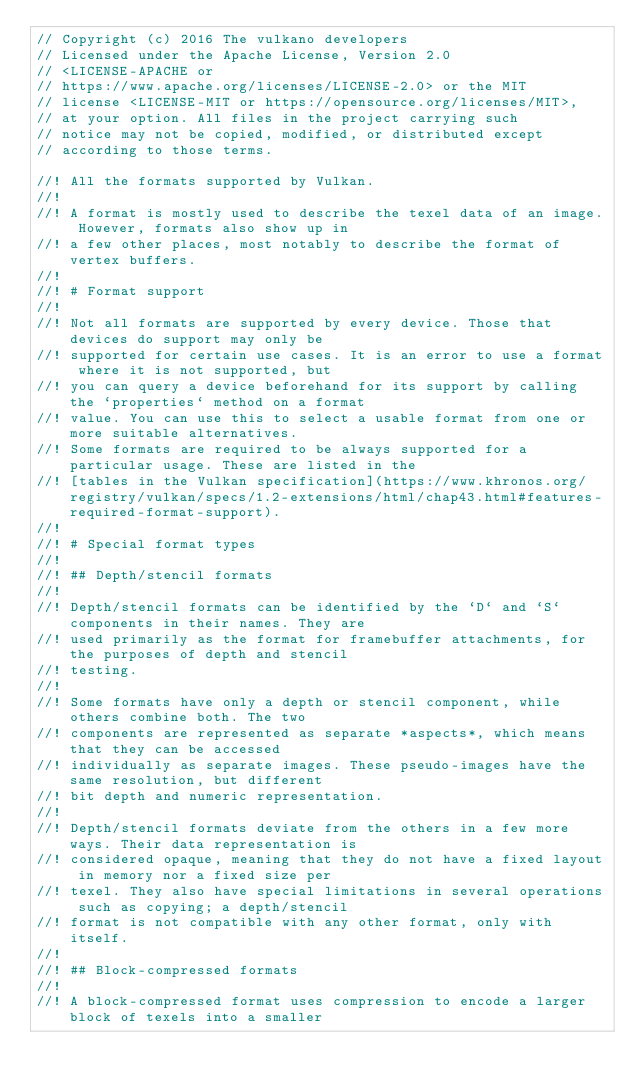Convert code to text. <code><loc_0><loc_0><loc_500><loc_500><_Rust_>// Copyright (c) 2016 The vulkano developers
// Licensed under the Apache License, Version 2.0
// <LICENSE-APACHE or
// https://www.apache.org/licenses/LICENSE-2.0> or the MIT
// license <LICENSE-MIT or https://opensource.org/licenses/MIT>,
// at your option. All files in the project carrying such
// notice may not be copied, modified, or distributed except
// according to those terms.

//! All the formats supported by Vulkan.
//!
//! A format is mostly used to describe the texel data of an image. However, formats also show up in
//! a few other places, most notably to describe the format of vertex buffers.
//!
//! # Format support
//!
//! Not all formats are supported by every device. Those that devices do support may only be
//! supported for certain use cases. It is an error to use a format where it is not supported, but
//! you can query a device beforehand for its support by calling the `properties` method on a format
//! value. You can use this to select a usable format from one or more suitable alternatives.
//! Some formats are required to be always supported for a particular usage. These are listed in the
//! [tables in the Vulkan specification](https://www.khronos.org/registry/vulkan/specs/1.2-extensions/html/chap43.html#features-required-format-support).
//!
//! # Special format types
//!
//! ## Depth/stencil formats
//!
//! Depth/stencil formats can be identified by the `D` and `S` components in their names. They are
//! used primarily as the format for framebuffer attachments, for the purposes of depth and stencil
//! testing.
//!
//! Some formats have only a depth or stencil component, while others combine both. The two
//! components are represented as separate *aspects*, which means that they can be accessed
//! individually as separate images. These pseudo-images have the same resolution, but different
//! bit depth and numeric representation.
//!
//! Depth/stencil formats deviate from the others in a few more ways. Their data representation is
//! considered opaque, meaning that they do not have a fixed layout in memory nor a fixed size per
//! texel. They also have special limitations in several operations such as copying; a depth/stencil
//! format is not compatible with any other format, only with itself.
//!
//! ## Block-compressed formats
//!
//! A block-compressed format uses compression to encode a larger block of texels into a smaller</code> 